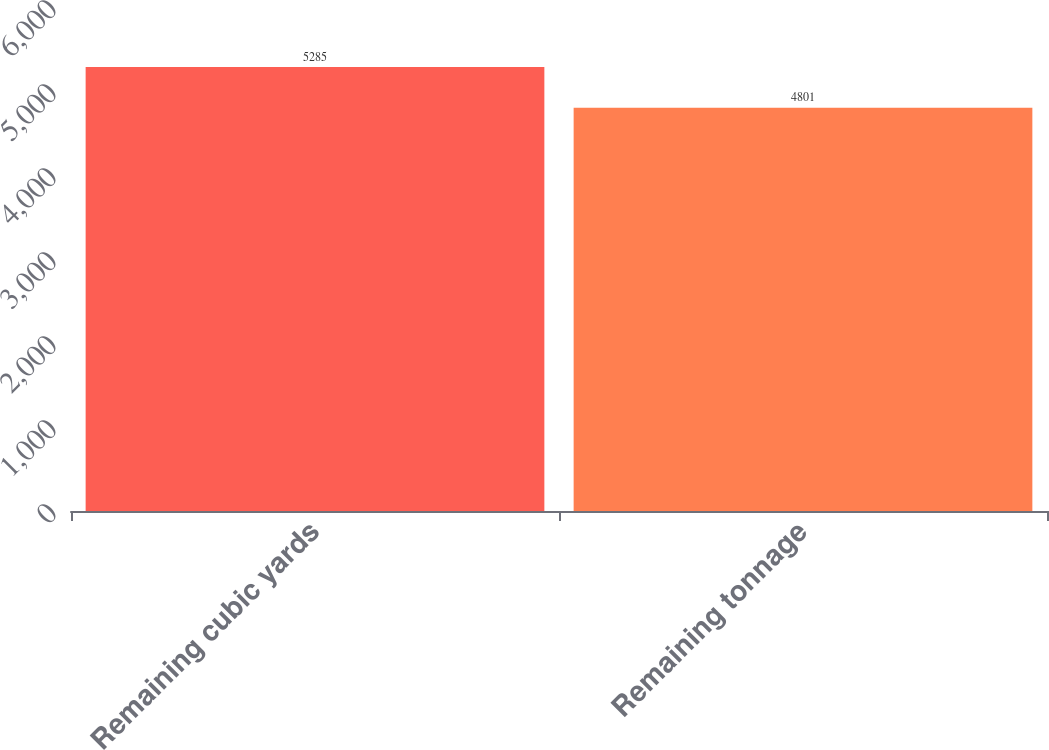<chart> <loc_0><loc_0><loc_500><loc_500><bar_chart><fcel>Remaining cubic yards<fcel>Remaining tonnage<nl><fcel>5285<fcel>4801<nl></chart> 